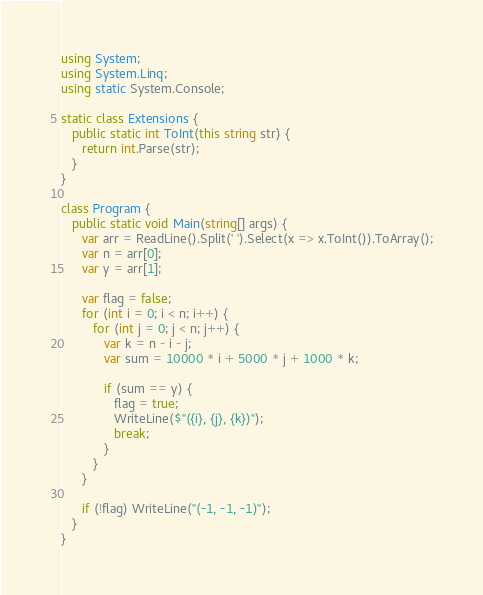Convert code to text. <code><loc_0><loc_0><loc_500><loc_500><_C#_>using System;
using System.Linq;
using static System.Console;

static class Extensions {
   public static int ToInt(this string str) {
      return int.Parse(str);
   }
}

class Program {
   public static void Main(string[] args) {
      var arr = ReadLine().Split(' ').Select(x => x.ToInt()).ToArray();
      var n = arr[0];
      var y = arr[1];

      var flag = false;
      for (int i = 0; i < n; i++) {
         for (int j = 0; j < n; j++) {
            var k = n - i - j;
            var sum = 10000 * i + 5000 * j + 1000 * k;
            
            if (sum == y) {
               flag = true;
               WriteLine($"({i}, {j}, {k})");
               break;
            }
         }
      }

      if (!flag) WriteLine("(-1, -1, -1)");
   }
}
</code> 